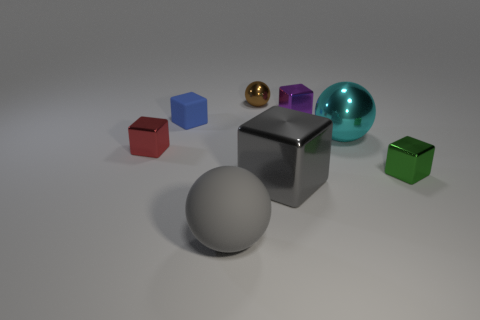There is a rubber ball that is the same color as the large block; what size is it?
Provide a succinct answer. Large. How many cubes are either big brown metallic objects or metal things?
Your answer should be very brief. 4. There is a tiny shiny thing that is in front of the small red metal thing; what number of tiny brown metallic spheres are left of it?
Your answer should be compact. 1. Do the large cyan metal object and the small brown object have the same shape?
Provide a succinct answer. Yes. There is a red metallic object that is the same shape as the small purple object; what size is it?
Keep it short and to the point. Small. There is a big gray thing that is behind the big sphere that is in front of the green object; what shape is it?
Offer a very short reply. Cube. What is the size of the brown thing?
Your answer should be compact. Small. The brown metallic object is what shape?
Provide a short and direct response. Sphere. There is a big cyan metal thing; does it have the same shape as the rubber object in front of the big cyan metallic ball?
Offer a terse response. Yes. There is a thing to the left of the tiny blue block; is its shape the same as the tiny green metal object?
Provide a short and direct response. Yes. 